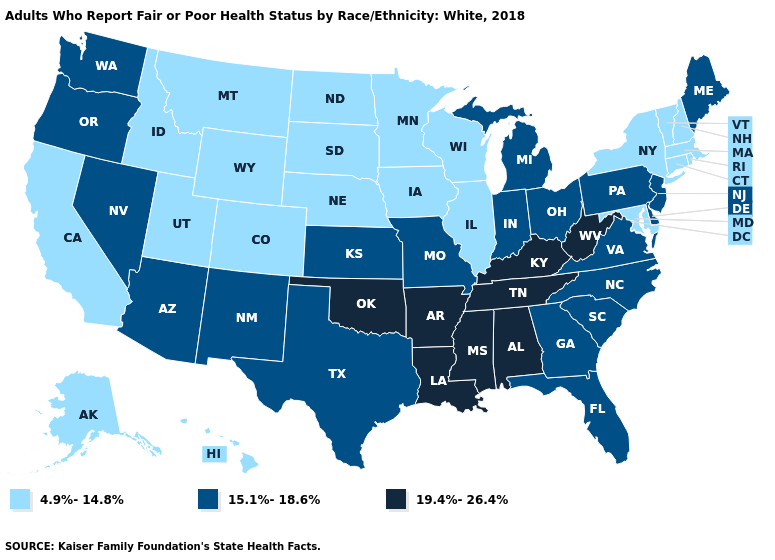What is the value of New Hampshire?
Be succinct. 4.9%-14.8%. Which states have the highest value in the USA?
Be succinct. Alabama, Arkansas, Kentucky, Louisiana, Mississippi, Oklahoma, Tennessee, West Virginia. What is the value of Massachusetts?
Short answer required. 4.9%-14.8%. Is the legend a continuous bar?
Short answer required. No. What is the value of Wyoming?
Write a very short answer. 4.9%-14.8%. Is the legend a continuous bar?
Quick response, please. No. Does Connecticut have the lowest value in the USA?
Concise answer only. Yes. Name the states that have a value in the range 19.4%-26.4%?
Short answer required. Alabama, Arkansas, Kentucky, Louisiana, Mississippi, Oklahoma, Tennessee, West Virginia. Name the states that have a value in the range 15.1%-18.6%?
Quick response, please. Arizona, Delaware, Florida, Georgia, Indiana, Kansas, Maine, Michigan, Missouri, Nevada, New Jersey, New Mexico, North Carolina, Ohio, Oregon, Pennsylvania, South Carolina, Texas, Virginia, Washington. What is the value of South Carolina?
Short answer required. 15.1%-18.6%. What is the lowest value in states that border Washington?
Concise answer only. 4.9%-14.8%. Is the legend a continuous bar?
Quick response, please. No. How many symbols are there in the legend?
Short answer required. 3. Does Georgia have the same value as Oklahoma?
Quick response, please. No. 